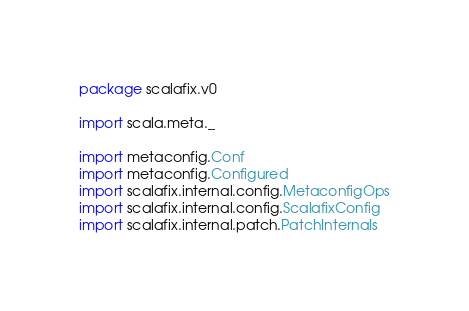<code> <loc_0><loc_0><loc_500><loc_500><_Scala_>package scalafix.v0

import scala.meta._

import metaconfig.Conf
import metaconfig.Configured
import scalafix.internal.config.MetaconfigOps
import scalafix.internal.config.ScalafixConfig
import scalafix.internal.patch.PatchInternals</code> 